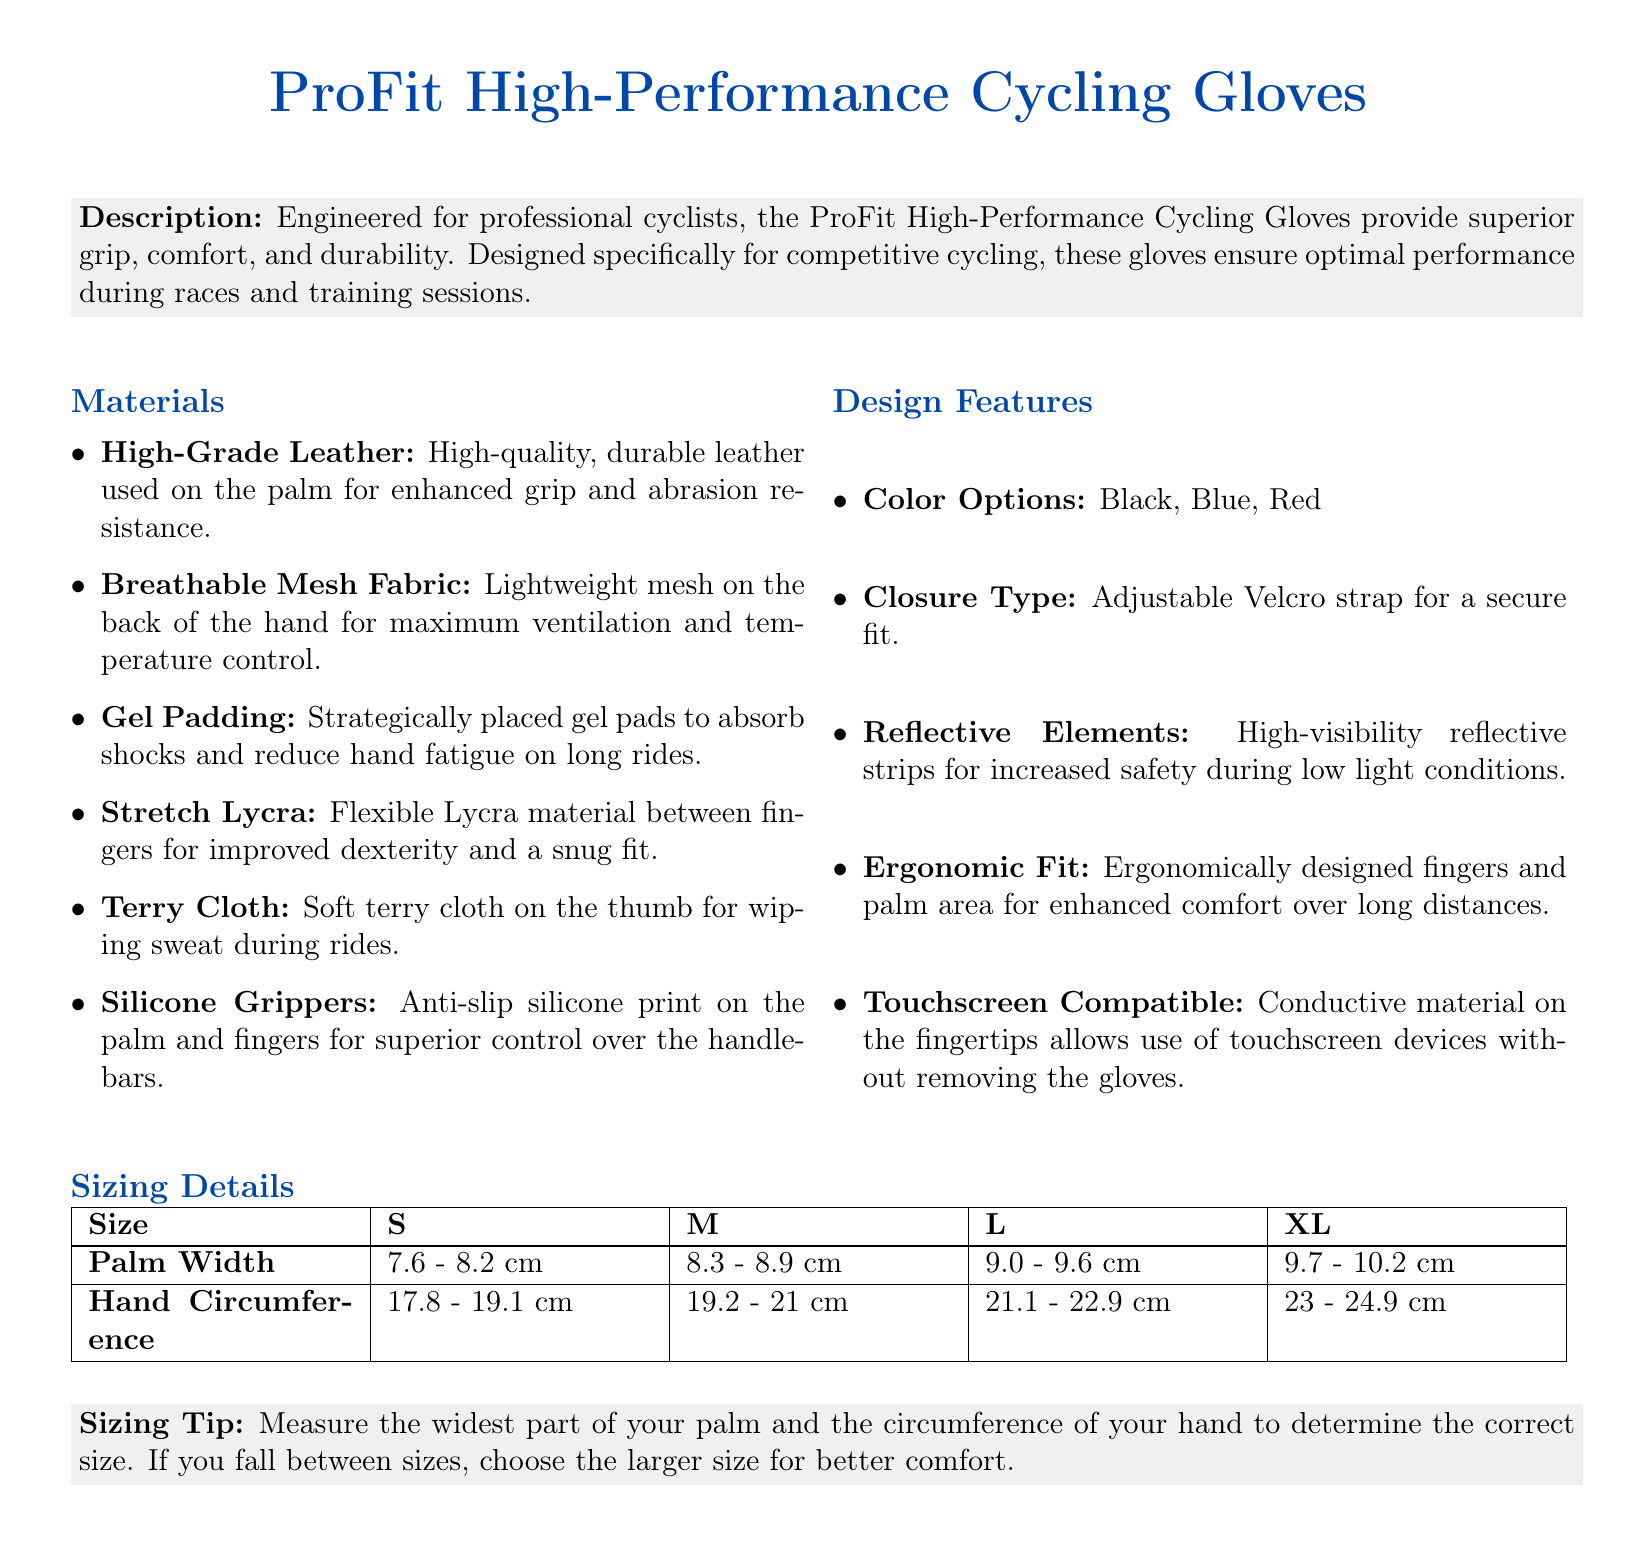what material is used on the palm of the gloves? The palm of the gloves is made of high-grade leather for enhanced grip and abrasion resistance.
Answer: high-grade leather what is the size range for medium gloves? The medium gloves fit a palm width of 8.3 - 8.9 cm and hand circumference of 19.2 - 21 cm.
Answer: 8.3 - 8.9 cm, 19.2 - 21 cm what design feature enhances safety during low light? Reflective strips provide increased safety during low light conditions.
Answer: reflective strips how many color options are available for these gloves? The document lists three color options for the gloves.
Answer: three what does the sizing tip recommend if you fall between sizes? The sizing tip suggests choosing the larger size for better comfort if you fall between sizes.
Answer: choose the larger size what type of closure is used in the gloves? The gloves use an adjustable Velcro strap as the closure type.
Answer: adjustable Velcro strap what is the main purpose of the gel padding in the gloves? The gel padding is designed to absorb shocks and reduce hand fatigue during long rides.
Answer: absorb shocks and reduce hand fatigue what feature allows use of touchscreen devices? The gloves are equipped with conductive material on the fingertips to allow touchscreen use.
Answer: conductive material on the fingertips 